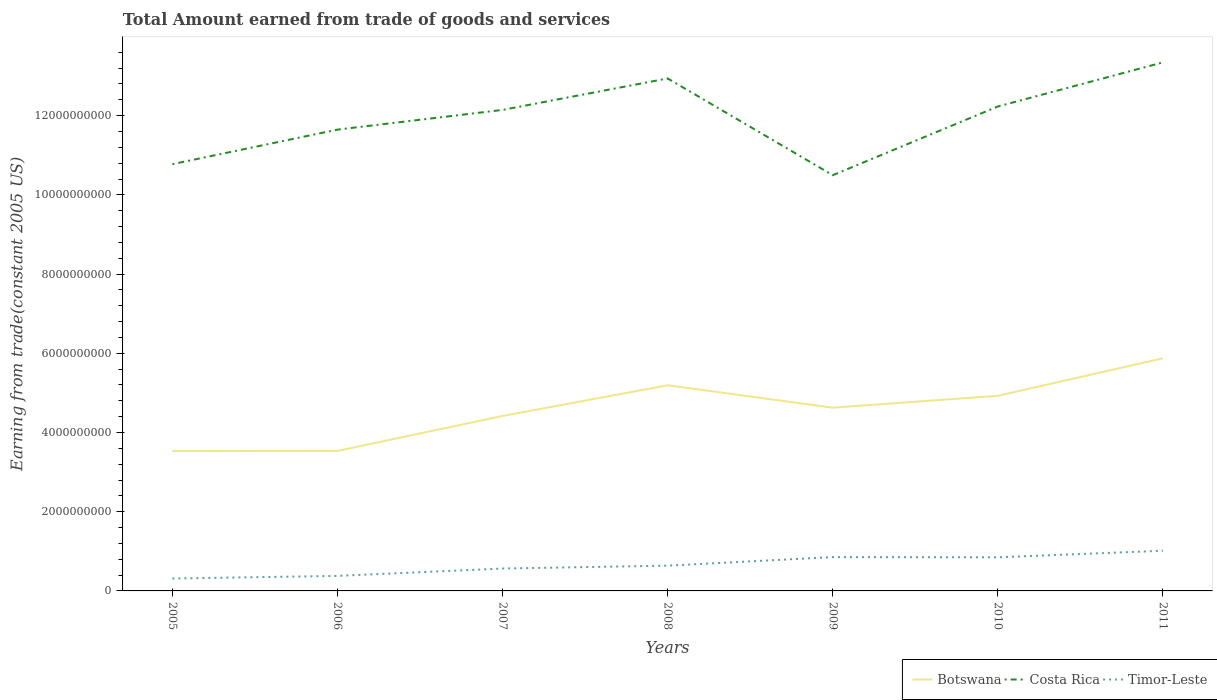Does the line corresponding to Costa Rica intersect with the line corresponding to Botswana?
Your answer should be compact. No. Is the number of lines equal to the number of legend labels?
Ensure brevity in your answer.  Yes. Across all years, what is the maximum total amount earned by trading goods and services in Timor-Leste?
Provide a short and direct response. 3.13e+08. What is the total total amount earned by trading goods and services in Costa Rica in the graph?
Provide a short and direct response. -7.94e+08. What is the difference between the highest and the second highest total amount earned by trading goods and services in Timor-Leste?
Give a very brief answer. 7.02e+08. What is the difference between the highest and the lowest total amount earned by trading goods and services in Timor-Leste?
Provide a succinct answer. 3. Is the total amount earned by trading goods and services in Timor-Leste strictly greater than the total amount earned by trading goods and services in Botswana over the years?
Provide a short and direct response. Yes. What is the difference between two consecutive major ticks on the Y-axis?
Your response must be concise. 2.00e+09. Are the values on the major ticks of Y-axis written in scientific E-notation?
Offer a terse response. No. How are the legend labels stacked?
Your answer should be very brief. Horizontal. What is the title of the graph?
Make the answer very short. Total Amount earned from trade of goods and services. Does "Europe(all income levels)" appear as one of the legend labels in the graph?
Keep it short and to the point. No. What is the label or title of the X-axis?
Your answer should be very brief. Years. What is the label or title of the Y-axis?
Your answer should be very brief. Earning from trade(constant 2005 US). What is the Earning from trade(constant 2005 US) in Botswana in 2005?
Offer a very short reply. 3.53e+09. What is the Earning from trade(constant 2005 US) of Costa Rica in 2005?
Your answer should be compact. 1.08e+1. What is the Earning from trade(constant 2005 US) of Timor-Leste in 2005?
Offer a very short reply. 3.13e+08. What is the Earning from trade(constant 2005 US) in Botswana in 2006?
Offer a very short reply. 3.54e+09. What is the Earning from trade(constant 2005 US) in Costa Rica in 2006?
Your answer should be compact. 1.16e+1. What is the Earning from trade(constant 2005 US) of Timor-Leste in 2006?
Ensure brevity in your answer.  3.80e+08. What is the Earning from trade(constant 2005 US) of Botswana in 2007?
Provide a succinct answer. 4.42e+09. What is the Earning from trade(constant 2005 US) of Costa Rica in 2007?
Offer a very short reply. 1.21e+1. What is the Earning from trade(constant 2005 US) of Timor-Leste in 2007?
Your answer should be compact. 5.66e+08. What is the Earning from trade(constant 2005 US) in Botswana in 2008?
Offer a very short reply. 5.19e+09. What is the Earning from trade(constant 2005 US) of Costa Rica in 2008?
Offer a very short reply. 1.29e+1. What is the Earning from trade(constant 2005 US) in Timor-Leste in 2008?
Provide a short and direct response. 6.38e+08. What is the Earning from trade(constant 2005 US) in Botswana in 2009?
Make the answer very short. 4.63e+09. What is the Earning from trade(constant 2005 US) in Costa Rica in 2009?
Make the answer very short. 1.05e+1. What is the Earning from trade(constant 2005 US) in Timor-Leste in 2009?
Keep it short and to the point. 8.54e+08. What is the Earning from trade(constant 2005 US) of Botswana in 2010?
Give a very brief answer. 4.93e+09. What is the Earning from trade(constant 2005 US) of Costa Rica in 2010?
Offer a very short reply. 1.22e+1. What is the Earning from trade(constant 2005 US) of Timor-Leste in 2010?
Ensure brevity in your answer.  8.49e+08. What is the Earning from trade(constant 2005 US) of Botswana in 2011?
Ensure brevity in your answer.  5.87e+09. What is the Earning from trade(constant 2005 US) in Costa Rica in 2011?
Give a very brief answer. 1.33e+1. What is the Earning from trade(constant 2005 US) of Timor-Leste in 2011?
Your answer should be compact. 1.02e+09. Across all years, what is the maximum Earning from trade(constant 2005 US) of Botswana?
Make the answer very short. 5.87e+09. Across all years, what is the maximum Earning from trade(constant 2005 US) of Costa Rica?
Provide a short and direct response. 1.33e+1. Across all years, what is the maximum Earning from trade(constant 2005 US) in Timor-Leste?
Offer a very short reply. 1.02e+09. Across all years, what is the minimum Earning from trade(constant 2005 US) in Botswana?
Your answer should be compact. 3.53e+09. Across all years, what is the minimum Earning from trade(constant 2005 US) in Costa Rica?
Make the answer very short. 1.05e+1. Across all years, what is the minimum Earning from trade(constant 2005 US) of Timor-Leste?
Your answer should be very brief. 3.13e+08. What is the total Earning from trade(constant 2005 US) in Botswana in the graph?
Your response must be concise. 3.21e+1. What is the total Earning from trade(constant 2005 US) in Costa Rica in the graph?
Ensure brevity in your answer.  8.36e+1. What is the total Earning from trade(constant 2005 US) in Timor-Leste in the graph?
Keep it short and to the point. 4.61e+09. What is the difference between the Earning from trade(constant 2005 US) in Botswana in 2005 and that in 2006?
Your answer should be compact. -1.56e+06. What is the difference between the Earning from trade(constant 2005 US) in Costa Rica in 2005 and that in 2006?
Your response must be concise. -8.72e+08. What is the difference between the Earning from trade(constant 2005 US) of Timor-Leste in 2005 and that in 2006?
Give a very brief answer. -6.67e+07. What is the difference between the Earning from trade(constant 2005 US) in Botswana in 2005 and that in 2007?
Provide a succinct answer. -8.84e+08. What is the difference between the Earning from trade(constant 2005 US) in Costa Rica in 2005 and that in 2007?
Ensure brevity in your answer.  -1.37e+09. What is the difference between the Earning from trade(constant 2005 US) of Timor-Leste in 2005 and that in 2007?
Provide a succinct answer. -2.53e+08. What is the difference between the Earning from trade(constant 2005 US) of Botswana in 2005 and that in 2008?
Provide a succinct answer. -1.66e+09. What is the difference between the Earning from trade(constant 2005 US) of Costa Rica in 2005 and that in 2008?
Ensure brevity in your answer.  -2.16e+09. What is the difference between the Earning from trade(constant 2005 US) in Timor-Leste in 2005 and that in 2008?
Your answer should be very brief. -3.25e+08. What is the difference between the Earning from trade(constant 2005 US) of Botswana in 2005 and that in 2009?
Offer a very short reply. -1.09e+09. What is the difference between the Earning from trade(constant 2005 US) of Costa Rica in 2005 and that in 2009?
Your response must be concise. 2.79e+08. What is the difference between the Earning from trade(constant 2005 US) of Timor-Leste in 2005 and that in 2009?
Keep it short and to the point. -5.41e+08. What is the difference between the Earning from trade(constant 2005 US) of Botswana in 2005 and that in 2010?
Ensure brevity in your answer.  -1.39e+09. What is the difference between the Earning from trade(constant 2005 US) in Costa Rica in 2005 and that in 2010?
Ensure brevity in your answer.  -1.46e+09. What is the difference between the Earning from trade(constant 2005 US) in Timor-Leste in 2005 and that in 2010?
Keep it short and to the point. -5.36e+08. What is the difference between the Earning from trade(constant 2005 US) in Botswana in 2005 and that in 2011?
Your answer should be compact. -2.34e+09. What is the difference between the Earning from trade(constant 2005 US) in Costa Rica in 2005 and that in 2011?
Keep it short and to the point. -2.57e+09. What is the difference between the Earning from trade(constant 2005 US) of Timor-Leste in 2005 and that in 2011?
Ensure brevity in your answer.  -7.02e+08. What is the difference between the Earning from trade(constant 2005 US) in Botswana in 2006 and that in 2007?
Your answer should be compact. -8.82e+08. What is the difference between the Earning from trade(constant 2005 US) in Costa Rica in 2006 and that in 2007?
Your answer should be very brief. -4.98e+08. What is the difference between the Earning from trade(constant 2005 US) of Timor-Leste in 2006 and that in 2007?
Keep it short and to the point. -1.86e+08. What is the difference between the Earning from trade(constant 2005 US) of Botswana in 2006 and that in 2008?
Provide a succinct answer. -1.66e+09. What is the difference between the Earning from trade(constant 2005 US) in Costa Rica in 2006 and that in 2008?
Offer a very short reply. -1.29e+09. What is the difference between the Earning from trade(constant 2005 US) of Timor-Leste in 2006 and that in 2008?
Provide a succinct answer. -2.58e+08. What is the difference between the Earning from trade(constant 2005 US) of Botswana in 2006 and that in 2009?
Your response must be concise. -1.09e+09. What is the difference between the Earning from trade(constant 2005 US) of Costa Rica in 2006 and that in 2009?
Your answer should be compact. 1.15e+09. What is the difference between the Earning from trade(constant 2005 US) in Timor-Leste in 2006 and that in 2009?
Your answer should be compact. -4.75e+08. What is the difference between the Earning from trade(constant 2005 US) in Botswana in 2006 and that in 2010?
Keep it short and to the point. -1.39e+09. What is the difference between the Earning from trade(constant 2005 US) in Costa Rica in 2006 and that in 2010?
Your answer should be very brief. -5.84e+08. What is the difference between the Earning from trade(constant 2005 US) in Timor-Leste in 2006 and that in 2010?
Keep it short and to the point. -4.69e+08. What is the difference between the Earning from trade(constant 2005 US) of Botswana in 2006 and that in 2011?
Keep it short and to the point. -2.34e+09. What is the difference between the Earning from trade(constant 2005 US) in Costa Rica in 2006 and that in 2011?
Offer a very short reply. -1.70e+09. What is the difference between the Earning from trade(constant 2005 US) in Timor-Leste in 2006 and that in 2011?
Make the answer very short. -6.35e+08. What is the difference between the Earning from trade(constant 2005 US) in Botswana in 2007 and that in 2008?
Your answer should be very brief. -7.75e+08. What is the difference between the Earning from trade(constant 2005 US) in Costa Rica in 2007 and that in 2008?
Ensure brevity in your answer.  -7.94e+08. What is the difference between the Earning from trade(constant 2005 US) in Timor-Leste in 2007 and that in 2008?
Your response must be concise. -7.22e+07. What is the difference between the Earning from trade(constant 2005 US) in Botswana in 2007 and that in 2009?
Provide a short and direct response. -2.10e+08. What is the difference between the Earning from trade(constant 2005 US) of Costa Rica in 2007 and that in 2009?
Your response must be concise. 1.65e+09. What is the difference between the Earning from trade(constant 2005 US) of Timor-Leste in 2007 and that in 2009?
Provide a succinct answer. -2.89e+08. What is the difference between the Earning from trade(constant 2005 US) of Botswana in 2007 and that in 2010?
Offer a terse response. -5.10e+08. What is the difference between the Earning from trade(constant 2005 US) in Costa Rica in 2007 and that in 2010?
Your response must be concise. -8.64e+07. What is the difference between the Earning from trade(constant 2005 US) of Timor-Leste in 2007 and that in 2010?
Make the answer very short. -2.83e+08. What is the difference between the Earning from trade(constant 2005 US) in Botswana in 2007 and that in 2011?
Your answer should be very brief. -1.46e+09. What is the difference between the Earning from trade(constant 2005 US) of Costa Rica in 2007 and that in 2011?
Provide a short and direct response. -1.20e+09. What is the difference between the Earning from trade(constant 2005 US) of Timor-Leste in 2007 and that in 2011?
Your answer should be compact. -4.49e+08. What is the difference between the Earning from trade(constant 2005 US) of Botswana in 2008 and that in 2009?
Make the answer very short. 5.65e+08. What is the difference between the Earning from trade(constant 2005 US) of Costa Rica in 2008 and that in 2009?
Provide a short and direct response. 2.44e+09. What is the difference between the Earning from trade(constant 2005 US) in Timor-Leste in 2008 and that in 2009?
Your answer should be very brief. -2.17e+08. What is the difference between the Earning from trade(constant 2005 US) in Botswana in 2008 and that in 2010?
Your response must be concise. 2.65e+08. What is the difference between the Earning from trade(constant 2005 US) in Costa Rica in 2008 and that in 2010?
Offer a terse response. 7.08e+08. What is the difference between the Earning from trade(constant 2005 US) in Timor-Leste in 2008 and that in 2010?
Provide a short and direct response. -2.11e+08. What is the difference between the Earning from trade(constant 2005 US) in Botswana in 2008 and that in 2011?
Your response must be concise. -6.82e+08. What is the difference between the Earning from trade(constant 2005 US) in Costa Rica in 2008 and that in 2011?
Offer a terse response. -4.06e+08. What is the difference between the Earning from trade(constant 2005 US) in Timor-Leste in 2008 and that in 2011?
Give a very brief answer. -3.77e+08. What is the difference between the Earning from trade(constant 2005 US) in Botswana in 2009 and that in 2010?
Your answer should be very brief. -3.00e+08. What is the difference between the Earning from trade(constant 2005 US) in Costa Rica in 2009 and that in 2010?
Your answer should be very brief. -1.74e+09. What is the difference between the Earning from trade(constant 2005 US) in Timor-Leste in 2009 and that in 2010?
Your answer should be very brief. 5.49e+06. What is the difference between the Earning from trade(constant 2005 US) of Botswana in 2009 and that in 2011?
Offer a terse response. -1.25e+09. What is the difference between the Earning from trade(constant 2005 US) in Costa Rica in 2009 and that in 2011?
Provide a succinct answer. -2.85e+09. What is the difference between the Earning from trade(constant 2005 US) of Timor-Leste in 2009 and that in 2011?
Give a very brief answer. -1.61e+08. What is the difference between the Earning from trade(constant 2005 US) in Botswana in 2010 and that in 2011?
Offer a terse response. -9.47e+08. What is the difference between the Earning from trade(constant 2005 US) of Costa Rica in 2010 and that in 2011?
Your answer should be compact. -1.11e+09. What is the difference between the Earning from trade(constant 2005 US) in Timor-Leste in 2010 and that in 2011?
Give a very brief answer. -1.66e+08. What is the difference between the Earning from trade(constant 2005 US) in Botswana in 2005 and the Earning from trade(constant 2005 US) in Costa Rica in 2006?
Your answer should be very brief. -8.11e+09. What is the difference between the Earning from trade(constant 2005 US) in Botswana in 2005 and the Earning from trade(constant 2005 US) in Timor-Leste in 2006?
Make the answer very short. 3.15e+09. What is the difference between the Earning from trade(constant 2005 US) of Costa Rica in 2005 and the Earning from trade(constant 2005 US) of Timor-Leste in 2006?
Offer a very short reply. 1.04e+1. What is the difference between the Earning from trade(constant 2005 US) in Botswana in 2005 and the Earning from trade(constant 2005 US) in Costa Rica in 2007?
Offer a very short reply. -8.61e+09. What is the difference between the Earning from trade(constant 2005 US) of Botswana in 2005 and the Earning from trade(constant 2005 US) of Timor-Leste in 2007?
Provide a succinct answer. 2.97e+09. What is the difference between the Earning from trade(constant 2005 US) of Costa Rica in 2005 and the Earning from trade(constant 2005 US) of Timor-Leste in 2007?
Ensure brevity in your answer.  1.02e+1. What is the difference between the Earning from trade(constant 2005 US) in Botswana in 2005 and the Earning from trade(constant 2005 US) in Costa Rica in 2008?
Make the answer very short. -9.41e+09. What is the difference between the Earning from trade(constant 2005 US) of Botswana in 2005 and the Earning from trade(constant 2005 US) of Timor-Leste in 2008?
Your answer should be very brief. 2.90e+09. What is the difference between the Earning from trade(constant 2005 US) in Costa Rica in 2005 and the Earning from trade(constant 2005 US) in Timor-Leste in 2008?
Provide a short and direct response. 1.01e+1. What is the difference between the Earning from trade(constant 2005 US) in Botswana in 2005 and the Earning from trade(constant 2005 US) in Costa Rica in 2009?
Your answer should be very brief. -6.96e+09. What is the difference between the Earning from trade(constant 2005 US) in Botswana in 2005 and the Earning from trade(constant 2005 US) in Timor-Leste in 2009?
Your response must be concise. 2.68e+09. What is the difference between the Earning from trade(constant 2005 US) in Costa Rica in 2005 and the Earning from trade(constant 2005 US) in Timor-Leste in 2009?
Ensure brevity in your answer.  9.92e+09. What is the difference between the Earning from trade(constant 2005 US) of Botswana in 2005 and the Earning from trade(constant 2005 US) of Costa Rica in 2010?
Your answer should be very brief. -8.70e+09. What is the difference between the Earning from trade(constant 2005 US) of Botswana in 2005 and the Earning from trade(constant 2005 US) of Timor-Leste in 2010?
Make the answer very short. 2.68e+09. What is the difference between the Earning from trade(constant 2005 US) in Costa Rica in 2005 and the Earning from trade(constant 2005 US) in Timor-Leste in 2010?
Keep it short and to the point. 9.93e+09. What is the difference between the Earning from trade(constant 2005 US) of Botswana in 2005 and the Earning from trade(constant 2005 US) of Costa Rica in 2011?
Your answer should be compact. -9.81e+09. What is the difference between the Earning from trade(constant 2005 US) of Botswana in 2005 and the Earning from trade(constant 2005 US) of Timor-Leste in 2011?
Offer a terse response. 2.52e+09. What is the difference between the Earning from trade(constant 2005 US) of Costa Rica in 2005 and the Earning from trade(constant 2005 US) of Timor-Leste in 2011?
Provide a succinct answer. 9.76e+09. What is the difference between the Earning from trade(constant 2005 US) of Botswana in 2006 and the Earning from trade(constant 2005 US) of Costa Rica in 2007?
Offer a very short reply. -8.61e+09. What is the difference between the Earning from trade(constant 2005 US) in Botswana in 2006 and the Earning from trade(constant 2005 US) in Timor-Leste in 2007?
Offer a terse response. 2.97e+09. What is the difference between the Earning from trade(constant 2005 US) in Costa Rica in 2006 and the Earning from trade(constant 2005 US) in Timor-Leste in 2007?
Offer a terse response. 1.11e+1. What is the difference between the Earning from trade(constant 2005 US) of Botswana in 2006 and the Earning from trade(constant 2005 US) of Costa Rica in 2008?
Offer a terse response. -9.40e+09. What is the difference between the Earning from trade(constant 2005 US) of Botswana in 2006 and the Earning from trade(constant 2005 US) of Timor-Leste in 2008?
Offer a terse response. 2.90e+09. What is the difference between the Earning from trade(constant 2005 US) of Costa Rica in 2006 and the Earning from trade(constant 2005 US) of Timor-Leste in 2008?
Your response must be concise. 1.10e+1. What is the difference between the Earning from trade(constant 2005 US) in Botswana in 2006 and the Earning from trade(constant 2005 US) in Costa Rica in 2009?
Offer a very short reply. -6.96e+09. What is the difference between the Earning from trade(constant 2005 US) of Botswana in 2006 and the Earning from trade(constant 2005 US) of Timor-Leste in 2009?
Offer a terse response. 2.68e+09. What is the difference between the Earning from trade(constant 2005 US) of Costa Rica in 2006 and the Earning from trade(constant 2005 US) of Timor-Leste in 2009?
Offer a very short reply. 1.08e+1. What is the difference between the Earning from trade(constant 2005 US) of Botswana in 2006 and the Earning from trade(constant 2005 US) of Costa Rica in 2010?
Your answer should be compact. -8.70e+09. What is the difference between the Earning from trade(constant 2005 US) in Botswana in 2006 and the Earning from trade(constant 2005 US) in Timor-Leste in 2010?
Keep it short and to the point. 2.69e+09. What is the difference between the Earning from trade(constant 2005 US) of Costa Rica in 2006 and the Earning from trade(constant 2005 US) of Timor-Leste in 2010?
Provide a short and direct response. 1.08e+1. What is the difference between the Earning from trade(constant 2005 US) in Botswana in 2006 and the Earning from trade(constant 2005 US) in Costa Rica in 2011?
Offer a terse response. -9.81e+09. What is the difference between the Earning from trade(constant 2005 US) of Botswana in 2006 and the Earning from trade(constant 2005 US) of Timor-Leste in 2011?
Your answer should be very brief. 2.52e+09. What is the difference between the Earning from trade(constant 2005 US) in Costa Rica in 2006 and the Earning from trade(constant 2005 US) in Timor-Leste in 2011?
Provide a short and direct response. 1.06e+1. What is the difference between the Earning from trade(constant 2005 US) in Botswana in 2007 and the Earning from trade(constant 2005 US) in Costa Rica in 2008?
Your answer should be very brief. -8.52e+09. What is the difference between the Earning from trade(constant 2005 US) of Botswana in 2007 and the Earning from trade(constant 2005 US) of Timor-Leste in 2008?
Your response must be concise. 3.78e+09. What is the difference between the Earning from trade(constant 2005 US) in Costa Rica in 2007 and the Earning from trade(constant 2005 US) in Timor-Leste in 2008?
Your response must be concise. 1.15e+1. What is the difference between the Earning from trade(constant 2005 US) of Botswana in 2007 and the Earning from trade(constant 2005 US) of Costa Rica in 2009?
Offer a terse response. -6.08e+09. What is the difference between the Earning from trade(constant 2005 US) in Botswana in 2007 and the Earning from trade(constant 2005 US) in Timor-Leste in 2009?
Keep it short and to the point. 3.56e+09. What is the difference between the Earning from trade(constant 2005 US) of Costa Rica in 2007 and the Earning from trade(constant 2005 US) of Timor-Leste in 2009?
Make the answer very short. 1.13e+1. What is the difference between the Earning from trade(constant 2005 US) in Botswana in 2007 and the Earning from trade(constant 2005 US) in Costa Rica in 2010?
Provide a succinct answer. -7.81e+09. What is the difference between the Earning from trade(constant 2005 US) in Botswana in 2007 and the Earning from trade(constant 2005 US) in Timor-Leste in 2010?
Provide a succinct answer. 3.57e+09. What is the difference between the Earning from trade(constant 2005 US) of Costa Rica in 2007 and the Earning from trade(constant 2005 US) of Timor-Leste in 2010?
Your response must be concise. 1.13e+1. What is the difference between the Earning from trade(constant 2005 US) in Botswana in 2007 and the Earning from trade(constant 2005 US) in Costa Rica in 2011?
Your answer should be compact. -8.93e+09. What is the difference between the Earning from trade(constant 2005 US) in Botswana in 2007 and the Earning from trade(constant 2005 US) in Timor-Leste in 2011?
Provide a succinct answer. 3.40e+09. What is the difference between the Earning from trade(constant 2005 US) of Costa Rica in 2007 and the Earning from trade(constant 2005 US) of Timor-Leste in 2011?
Offer a very short reply. 1.11e+1. What is the difference between the Earning from trade(constant 2005 US) of Botswana in 2008 and the Earning from trade(constant 2005 US) of Costa Rica in 2009?
Your answer should be very brief. -5.30e+09. What is the difference between the Earning from trade(constant 2005 US) in Botswana in 2008 and the Earning from trade(constant 2005 US) in Timor-Leste in 2009?
Give a very brief answer. 4.34e+09. What is the difference between the Earning from trade(constant 2005 US) in Costa Rica in 2008 and the Earning from trade(constant 2005 US) in Timor-Leste in 2009?
Ensure brevity in your answer.  1.21e+1. What is the difference between the Earning from trade(constant 2005 US) in Botswana in 2008 and the Earning from trade(constant 2005 US) in Costa Rica in 2010?
Provide a succinct answer. -7.04e+09. What is the difference between the Earning from trade(constant 2005 US) of Botswana in 2008 and the Earning from trade(constant 2005 US) of Timor-Leste in 2010?
Keep it short and to the point. 4.34e+09. What is the difference between the Earning from trade(constant 2005 US) of Costa Rica in 2008 and the Earning from trade(constant 2005 US) of Timor-Leste in 2010?
Offer a very short reply. 1.21e+1. What is the difference between the Earning from trade(constant 2005 US) in Botswana in 2008 and the Earning from trade(constant 2005 US) in Costa Rica in 2011?
Your answer should be compact. -8.15e+09. What is the difference between the Earning from trade(constant 2005 US) of Botswana in 2008 and the Earning from trade(constant 2005 US) of Timor-Leste in 2011?
Offer a terse response. 4.18e+09. What is the difference between the Earning from trade(constant 2005 US) of Costa Rica in 2008 and the Earning from trade(constant 2005 US) of Timor-Leste in 2011?
Make the answer very short. 1.19e+1. What is the difference between the Earning from trade(constant 2005 US) of Botswana in 2009 and the Earning from trade(constant 2005 US) of Costa Rica in 2010?
Your response must be concise. -7.60e+09. What is the difference between the Earning from trade(constant 2005 US) of Botswana in 2009 and the Earning from trade(constant 2005 US) of Timor-Leste in 2010?
Provide a succinct answer. 3.78e+09. What is the difference between the Earning from trade(constant 2005 US) in Costa Rica in 2009 and the Earning from trade(constant 2005 US) in Timor-Leste in 2010?
Provide a short and direct response. 9.65e+09. What is the difference between the Earning from trade(constant 2005 US) of Botswana in 2009 and the Earning from trade(constant 2005 US) of Costa Rica in 2011?
Your answer should be very brief. -8.72e+09. What is the difference between the Earning from trade(constant 2005 US) of Botswana in 2009 and the Earning from trade(constant 2005 US) of Timor-Leste in 2011?
Offer a terse response. 3.61e+09. What is the difference between the Earning from trade(constant 2005 US) in Costa Rica in 2009 and the Earning from trade(constant 2005 US) in Timor-Leste in 2011?
Make the answer very short. 9.48e+09. What is the difference between the Earning from trade(constant 2005 US) of Botswana in 2010 and the Earning from trade(constant 2005 US) of Costa Rica in 2011?
Provide a short and direct response. -8.42e+09. What is the difference between the Earning from trade(constant 2005 US) in Botswana in 2010 and the Earning from trade(constant 2005 US) in Timor-Leste in 2011?
Offer a very short reply. 3.91e+09. What is the difference between the Earning from trade(constant 2005 US) in Costa Rica in 2010 and the Earning from trade(constant 2005 US) in Timor-Leste in 2011?
Your answer should be very brief. 1.12e+1. What is the average Earning from trade(constant 2005 US) in Botswana per year?
Keep it short and to the point. 4.59e+09. What is the average Earning from trade(constant 2005 US) of Costa Rica per year?
Your answer should be very brief. 1.19e+1. What is the average Earning from trade(constant 2005 US) of Timor-Leste per year?
Your response must be concise. 6.59e+08. In the year 2005, what is the difference between the Earning from trade(constant 2005 US) of Botswana and Earning from trade(constant 2005 US) of Costa Rica?
Ensure brevity in your answer.  -7.24e+09. In the year 2005, what is the difference between the Earning from trade(constant 2005 US) in Botswana and Earning from trade(constant 2005 US) in Timor-Leste?
Offer a very short reply. 3.22e+09. In the year 2005, what is the difference between the Earning from trade(constant 2005 US) in Costa Rica and Earning from trade(constant 2005 US) in Timor-Leste?
Provide a short and direct response. 1.05e+1. In the year 2006, what is the difference between the Earning from trade(constant 2005 US) in Botswana and Earning from trade(constant 2005 US) in Costa Rica?
Your response must be concise. -8.11e+09. In the year 2006, what is the difference between the Earning from trade(constant 2005 US) of Botswana and Earning from trade(constant 2005 US) of Timor-Leste?
Your answer should be compact. 3.16e+09. In the year 2006, what is the difference between the Earning from trade(constant 2005 US) in Costa Rica and Earning from trade(constant 2005 US) in Timor-Leste?
Provide a short and direct response. 1.13e+1. In the year 2007, what is the difference between the Earning from trade(constant 2005 US) in Botswana and Earning from trade(constant 2005 US) in Costa Rica?
Your response must be concise. -7.73e+09. In the year 2007, what is the difference between the Earning from trade(constant 2005 US) of Botswana and Earning from trade(constant 2005 US) of Timor-Leste?
Offer a terse response. 3.85e+09. In the year 2007, what is the difference between the Earning from trade(constant 2005 US) in Costa Rica and Earning from trade(constant 2005 US) in Timor-Leste?
Your answer should be very brief. 1.16e+1. In the year 2008, what is the difference between the Earning from trade(constant 2005 US) in Botswana and Earning from trade(constant 2005 US) in Costa Rica?
Make the answer very short. -7.75e+09. In the year 2008, what is the difference between the Earning from trade(constant 2005 US) of Botswana and Earning from trade(constant 2005 US) of Timor-Leste?
Provide a succinct answer. 4.55e+09. In the year 2008, what is the difference between the Earning from trade(constant 2005 US) in Costa Rica and Earning from trade(constant 2005 US) in Timor-Leste?
Provide a succinct answer. 1.23e+1. In the year 2009, what is the difference between the Earning from trade(constant 2005 US) in Botswana and Earning from trade(constant 2005 US) in Costa Rica?
Your answer should be compact. -5.87e+09. In the year 2009, what is the difference between the Earning from trade(constant 2005 US) of Botswana and Earning from trade(constant 2005 US) of Timor-Leste?
Provide a short and direct response. 3.77e+09. In the year 2009, what is the difference between the Earning from trade(constant 2005 US) in Costa Rica and Earning from trade(constant 2005 US) in Timor-Leste?
Provide a succinct answer. 9.64e+09. In the year 2010, what is the difference between the Earning from trade(constant 2005 US) of Botswana and Earning from trade(constant 2005 US) of Costa Rica?
Keep it short and to the point. -7.31e+09. In the year 2010, what is the difference between the Earning from trade(constant 2005 US) in Botswana and Earning from trade(constant 2005 US) in Timor-Leste?
Offer a very short reply. 4.08e+09. In the year 2010, what is the difference between the Earning from trade(constant 2005 US) in Costa Rica and Earning from trade(constant 2005 US) in Timor-Leste?
Provide a short and direct response. 1.14e+1. In the year 2011, what is the difference between the Earning from trade(constant 2005 US) in Botswana and Earning from trade(constant 2005 US) in Costa Rica?
Give a very brief answer. -7.47e+09. In the year 2011, what is the difference between the Earning from trade(constant 2005 US) of Botswana and Earning from trade(constant 2005 US) of Timor-Leste?
Provide a succinct answer. 4.86e+09. In the year 2011, what is the difference between the Earning from trade(constant 2005 US) in Costa Rica and Earning from trade(constant 2005 US) in Timor-Leste?
Provide a short and direct response. 1.23e+1. What is the ratio of the Earning from trade(constant 2005 US) in Costa Rica in 2005 to that in 2006?
Provide a succinct answer. 0.93. What is the ratio of the Earning from trade(constant 2005 US) of Timor-Leste in 2005 to that in 2006?
Provide a short and direct response. 0.82. What is the ratio of the Earning from trade(constant 2005 US) in Botswana in 2005 to that in 2007?
Keep it short and to the point. 0.8. What is the ratio of the Earning from trade(constant 2005 US) of Costa Rica in 2005 to that in 2007?
Provide a short and direct response. 0.89. What is the ratio of the Earning from trade(constant 2005 US) of Timor-Leste in 2005 to that in 2007?
Make the answer very short. 0.55. What is the ratio of the Earning from trade(constant 2005 US) in Botswana in 2005 to that in 2008?
Give a very brief answer. 0.68. What is the ratio of the Earning from trade(constant 2005 US) in Costa Rica in 2005 to that in 2008?
Your answer should be compact. 0.83. What is the ratio of the Earning from trade(constant 2005 US) of Timor-Leste in 2005 to that in 2008?
Ensure brevity in your answer.  0.49. What is the ratio of the Earning from trade(constant 2005 US) of Botswana in 2005 to that in 2009?
Offer a very short reply. 0.76. What is the ratio of the Earning from trade(constant 2005 US) of Costa Rica in 2005 to that in 2009?
Give a very brief answer. 1.03. What is the ratio of the Earning from trade(constant 2005 US) of Timor-Leste in 2005 to that in 2009?
Provide a succinct answer. 0.37. What is the ratio of the Earning from trade(constant 2005 US) in Botswana in 2005 to that in 2010?
Keep it short and to the point. 0.72. What is the ratio of the Earning from trade(constant 2005 US) in Costa Rica in 2005 to that in 2010?
Provide a succinct answer. 0.88. What is the ratio of the Earning from trade(constant 2005 US) in Timor-Leste in 2005 to that in 2010?
Make the answer very short. 0.37. What is the ratio of the Earning from trade(constant 2005 US) in Botswana in 2005 to that in 2011?
Your answer should be very brief. 0.6. What is the ratio of the Earning from trade(constant 2005 US) of Costa Rica in 2005 to that in 2011?
Your response must be concise. 0.81. What is the ratio of the Earning from trade(constant 2005 US) in Timor-Leste in 2005 to that in 2011?
Your answer should be very brief. 0.31. What is the ratio of the Earning from trade(constant 2005 US) of Botswana in 2006 to that in 2007?
Offer a very short reply. 0.8. What is the ratio of the Earning from trade(constant 2005 US) in Timor-Leste in 2006 to that in 2007?
Provide a short and direct response. 0.67. What is the ratio of the Earning from trade(constant 2005 US) of Botswana in 2006 to that in 2008?
Provide a short and direct response. 0.68. What is the ratio of the Earning from trade(constant 2005 US) in Costa Rica in 2006 to that in 2008?
Your answer should be compact. 0.9. What is the ratio of the Earning from trade(constant 2005 US) of Timor-Leste in 2006 to that in 2008?
Keep it short and to the point. 0.6. What is the ratio of the Earning from trade(constant 2005 US) in Botswana in 2006 to that in 2009?
Keep it short and to the point. 0.76. What is the ratio of the Earning from trade(constant 2005 US) of Costa Rica in 2006 to that in 2009?
Provide a short and direct response. 1.11. What is the ratio of the Earning from trade(constant 2005 US) of Timor-Leste in 2006 to that in 2009?
Ensure brevity in your answer.  0.44. What is the ratio of the Earning from trade(constant 2005 US) of Botswana in 2006 to that in 2010?
Provide a short and direct response. 0.72. What is the ratio of the Earning from trade(constant 2005 US) of Costa Rica in 2006 to that in 2010?
Provide a short and direct response. 0.95. What is the ratio of the Earning from trade(constant 2005 US) of Timor-Leste in 2006 to that in 2010?
Give a very brief answer. 0.45. What is the ratio of the Earning from trade(constant 2005 US) of Botswana in 2006 to that in 2011?
Make the answer very short. 0.6. What is the ratio of the Earning from trade(constant 2005 US) in Costa Rica in 2006 to that in 2011?
Offer a very short reply. 0.87. What is the ratio of the Earning from trade(constant 2005 US) of Timor-Leste in 2006 to that in 2011?
Keep it short and to the point. 0.37. What is the ratio of the Earning from trade(constant 2005 US) in Botswana in 2007 to that in 2008?
Give a very brief answer. 0.85. What is the ratio of the Earning from trade(constant 2005 US) of Costa Rica in 2007 to that in 2008?
Make the answer very short. 0.94. What is the ratio of the Earning from trade(constant 2005 US) in Timor-Leste in 2007 to that in 2008?
Make the answer very short. 0.89. What is the ratio of the Earning from trade(constant 2005 US) in Botswana in 2007 to that in 2009?
Offer a very short reply. 0.95. What is the ratio of the Earning from trade(constant 2005 US) of Costa Rica in 2007 to that in 2009?
Your answer should be compact. 1.16. What is the ratio of the Earning from trade(constant 2005 US) of Timor-Leste in 2007 to that in 2009?
Ensure brevity in your answer.  0.66. What is the ratio of the Earning from trade(constant 2005 US) in Botswana in 2007 to that in 2010?
Your response must be concise. 0.9. What is the ratio of the Earning from trade(constant 2005 US) in Timor-Leste in 2007 to that in 2010?
Ensure brevity in your answer.  0.67. What is the ratio of the Earning from trade(constant 2005 US) in Botswana in 2007 to that in 2011?
Keep it short and to the point. 0.75. What is the ratio of the Earning from trade(constant 2005 US) in Costa Rica in 2007 to that in 2011?
Provide a succinct answer. 0.91. What is the ratio of the Earning from trade(constant 2005 US) of Timor-Leste in 2007 to that in 2011?
Give a very brief answer. 0.56. What is the ratio of the Earning from trade(constant 2005 US) in Botswana in 2008 to that in 2009?
Your answer should be compact. 1.12. What is the ratio of the Earning from trade(constant 2005 US) of Costa Rica in 2008 to that in 2009?
Give a very brief answer. 1.23. What is the ratio of the Earning from trade(constant 2005 US) in Timor-Leste in 2008 to that in 2009?
Your answer should be very brief. 0.75. What is the ratio of the Earning from trade(constant 2005 US) in Botswana in 2008 to that in 2010?
Provide a succinct answer. 1.05. What is the ratio of the Earning from trade(constant 2005 US) in Costa Rica in 2008 to that in 2010?
Ensure brevity in your answer.  1.06. What is the ratio of the Earning from trade(constant 2005 US) of Timor-Leste in 2008 to that in 2010?
Ensure brevity in your answer.  0.75. What is the ratio of the Earning from trade(constant 2005 US) of Botswana in 2008 to that in 2011?
Provide a short and direct response. 0.88. What is the ratio of the Earning from trade(constant 2005 US) in Costa Rica in 2008 to that in 2011?
Offer a very short reply. 0.97. What is the ratio of the Earning from trade(constant 2005 US) of Timor-Leste in 2008 to that in 2011?
Give a very brief answer. 0.63. What is the ratio of the Earning from trade(constant 2005 US) of Botswana in 2009 to that in 2010?
Offer a very short reply. 0.94. What is the ratio of the Earning from trade(constant 2005 US) in Costa Rica in 2009 to that in 2010?
Your answer should be compact. 0.86. What is the ratio of the Earning from trade(constant 2005 US) of Timor-Leste in 2009 to that in 2010?
Provide a succinct answer. 1.01. What is the ratio of the Earning from trade(constant 2005 US) in Botswana in 2009 to that in 2011?
Make the answer very short. 0.79. What is the ratio of the Earning from trade(constant 2005 US) in Costa Rica in 2009 to that in 2011?
Ensure brevity in your answer.  0.79. What is the ratio of the Earning from trade(constant 2005 US) in Timor-Leste in 2009 to that in 2011?
Provide a succinct answer. 0.84. What is the ratio of the Earning from trade(constant 2005 US) in Botswana in 2010 to that in 2011?
Offer a terse response. 0.84. What is the ratio of the Earning from trade(constant 2005 US) of Costa Rica in 2010 to that in 2011?
Make the answer very short. 0.92. What is the ratio of the Earning from trade(constant 2005 US) in Timor-Leste in 2010 to that in 2011?
Your response must be concise. 0.84. What is the difference between the highest and the second highest Earning from trade(constant 2005 US) of Botswana?
Offer a terse response. 6.82e+08. What is the difference between the highest and the second highest Earning from trade(constant 2005 US) in Costa Rica?
Your answer should be compact. 4.06e+08. What is the difference between the highest and the second highest Earning from trade(constant 2005 US) in Timor-Leste?
Provide a succinct answer. 1.61e+08. What is the difference between the highest and the lowest Earning from trade(constant 2005 US) of Botswana?
Provide a short and direct response. 2.34e+09. What is the difference between the highest and the lowest Earning from trade(constant 2005 US) of Costa Rica?
Your answer should be very brief. 2.85e+09. What is the difference between the highest and the lowest Earning from trade(constant 2005 US) of Timor-Leste?
Make the answer very short. 7.02e+08. 